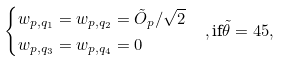<formula> <loc_0><loc_0><loc_500><loc_500>& \begin{cases} w _ { p , q _ { 1 } } = w _ { p , q _ { 2 } } = \tilde { O } _ { p } / \sqrt { 2 } \\ w _ { p , q _ { 3 } } = w _ { p , q _ { 4 } } = 0 \end{cases} , \text {if} \tilde { \theta } = 4 5 ,</formula> 